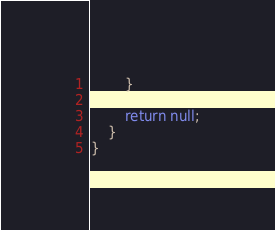Convert code to text. <code><loc_0><loc_0><loc_500><loc_500><_C#_>        }

        return null;
    }
}
</code> 